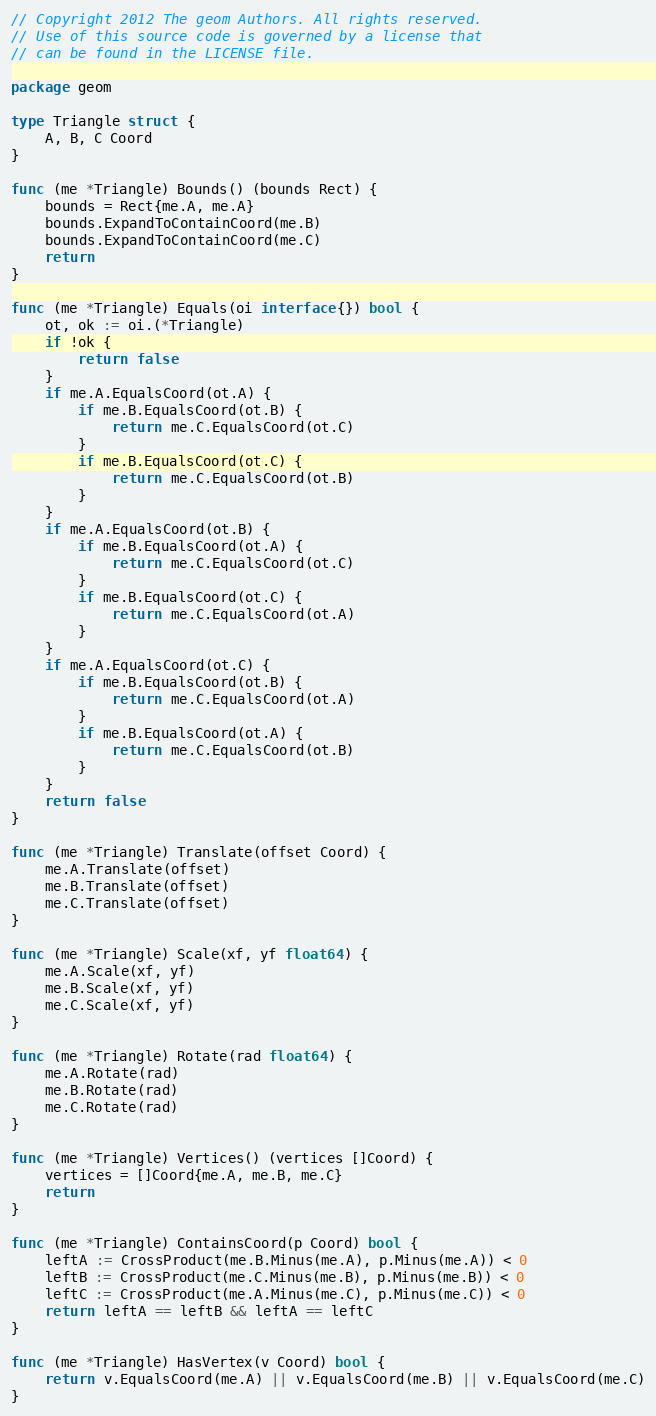<code> <loc_0><loc_0><loc_500><loc_500><_Go_>// Copyright 2012 The geom Authors. All rights reserved.
// Use of this source code is governed by a license that
// can be found in the LICENSE file.

package geom

type Triangle struct {
	A, B, C Coord
}

func (me *Triangle) Bounds() (bounds Rect) {
	bounds = Rect{me.A, me.A}
	bounds.ExpandToContainCoord(me.B)
	bounds.ExpandToContainCoord(me.C)
	return
}

func (me *Triangle) Equals(oi interface{}) bool {
	ot, ok := oi.(*Triangle)
	if !ok {
		return false
	}
	if me.A.EqualsCoord(ot.A) {
		if me.B.EqualsCoord(ot.B) {
			return me.C.EqualsCoord(ot.C)
		}
		if me.B.EqualsCoord(ot.C) {
			return me.C.EqualsCoord(ot.B)
		}
	}
	if me.A.EqualsCoord(ot.B) {
		if me.B.EqualsCoord(ot.A) {
			return me.C.EqualsCoord(ot.C)
		}
		if me.B.EqualsCoord(ot.C) {
			return me.C.EqualsCoord(ot.A)
		}
	}
	if me.A.EqualsCoord(ot.C) {
		if me.B.EqualsCoord(ot.B) {
			return me.C.EqualsCoord(ot.A)
		}
		if me.B.EqualsCoord(ot.A) {
			return me.C.EqualsCoord(ot.B)
		}
	}
	return false
}

func (me *Triangle) Translate(offset Coord) {
	me.A.Translate(offset)
	me.B.Translate(offset)
	me.C.Translate(offset)
}

func (me *Triangle) Scale(xf, yf float64) {
	me.A.Scale(xf, yf)
	me.B.Scale(xf, yf)
	me.C.Scale(xf, yf)
}

func (me *Triangle) Rotate(rad float64) {
	me.A.Rotate(rad)
	me.B.Rotate(rad)
	me.C.Rotate(rad)
}

func (me *Triangle) Vertices() (vertices []Coord) {
	vertices = []Coord{me.A, me.B, me.C}
	return
}

func (me *Triangle) ContainsCoord(p Coord) bool {
	leftA := CrossProduct(me.B.Minus(me.A), p.Minus(me.A)) < 0
	leftB := CrossProduct(me.C.Minus(me.B), p.Minus(me.B)) < 0
	leftC := CrossProduct(me.A.Minus(me.C), p.Minus(me.C)) < 0
	return leftA == leftB && leftA == leftC
}

func (me *Triangle) HasVertex(v Coord) bool {
	return v.EqualsCoord(me.A) || v.EqualsCoord(me.B) || v.EqualsCoord(me.C)
}
</code> 